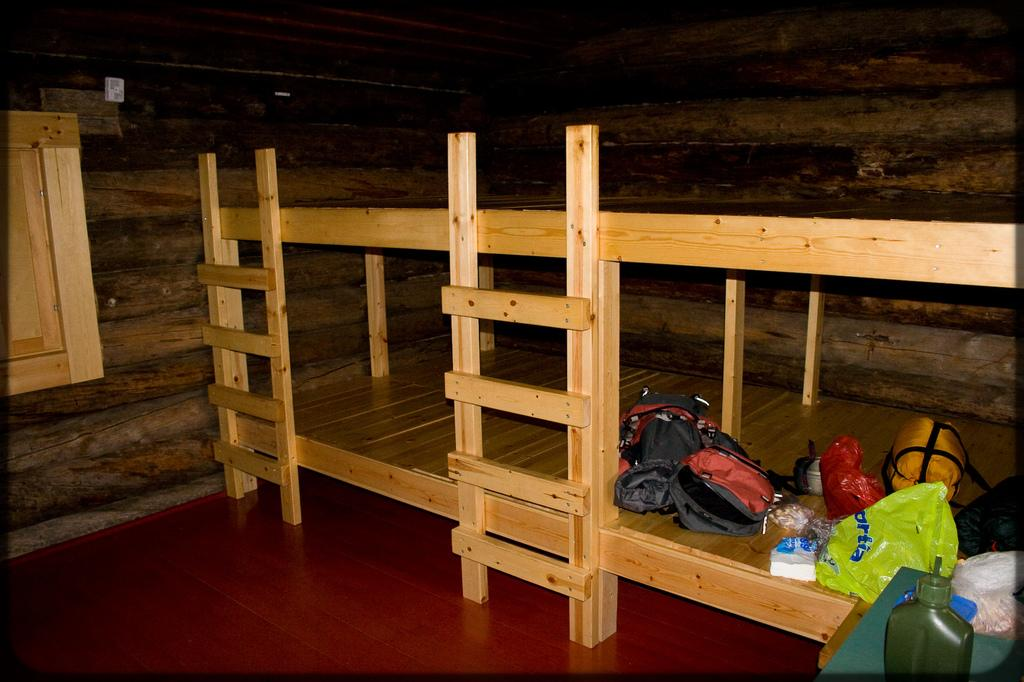What type of bed is shown in the image? There is a wooden bed with two levels in the image. What can be seen on the bed? Many objects are placed on the bed. What material is used for the background in the image? The background of the image is made of wood. How many lizards are crawling on the bed in the image? There are no lizards present in the image. What level of the bed is the actor sitting on? There is no actor present in the image, and the bed has only two levels, not three. 